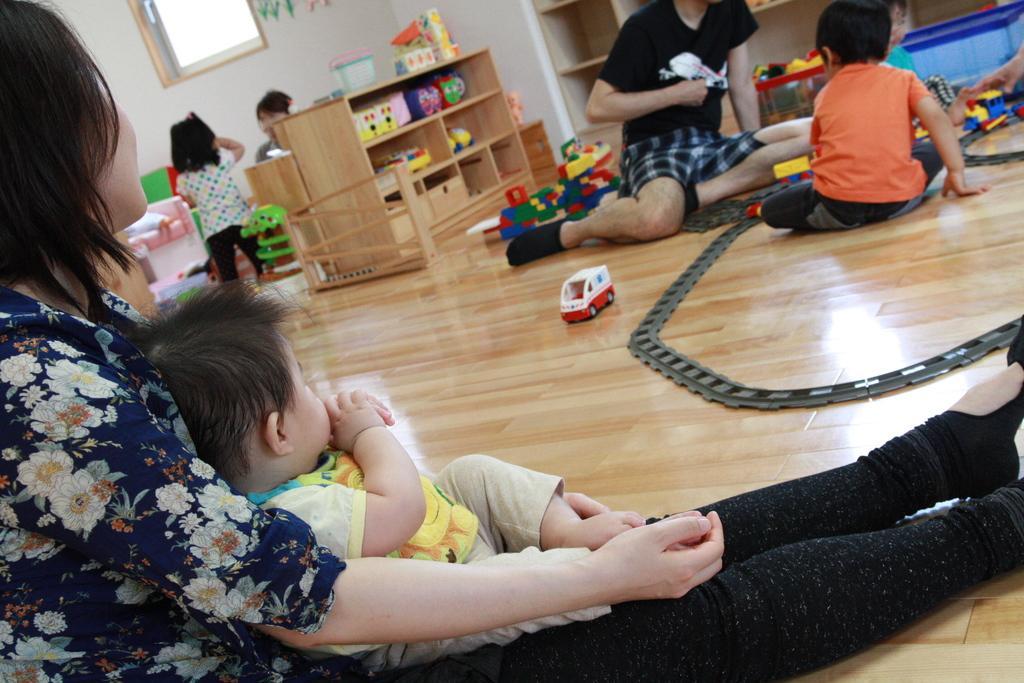How would you summarize this image in a sentence or two? In this image there are elders and children sitting on floor beside them there are some toys and wooden self with other toys, also there is a window on wall. 